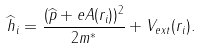<formula> <loc_0><loc_0><loc_500><loc_500>\widehat { h } _ { i } = \frac { ( \widehat { p } + e { A } ( { r } _ { i } ) ) ^ { 2 } } { 2 m ^ { * } } + V _ { e x t } ( r _ { i } ) .</formula> 